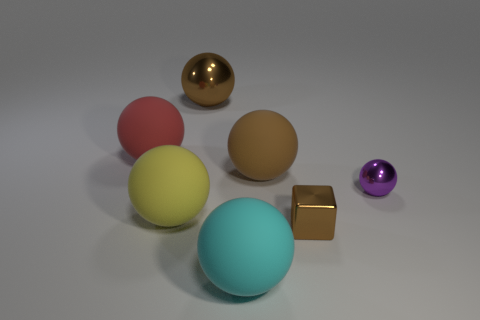There is a big yellow matte ball; what number of large things are behind it?
Give a very brief answer. 3. How many purple things are there?
Provide a succinct answer. 1. Does the brown cube have the same size as the purple shiny thing?
Offer a terse response. Yes. There is a brown shiny thing that is behind the big sphere left of the big yellow matte thing; is there a big matte object to the left of it?
Ensure brevity in your answer.  Yes. There is another tiny object that is the same shape as the brown rubber object; what material is it?
Your response must be concise. Metal. There is a rubber sphere in front of the big yellow matte ball; what color is it?
Offer a terse response. Cyan. What size is the metallic cube?
Ensure brevity in your answer.  Small. There is a yellow ball; does it have the same size as the brown thing on the left side of the cyan rubber object?
Your answer should be compact. Yes. There is a shiny thing left of the big brown sphere right of the sphere that is behind the large red matte ball; what is its color?
Your response must be concise. Brown. Do the big thing that is in front of the small brown cube and the tiny brown object have the same material?
Offer a terse response. No. 